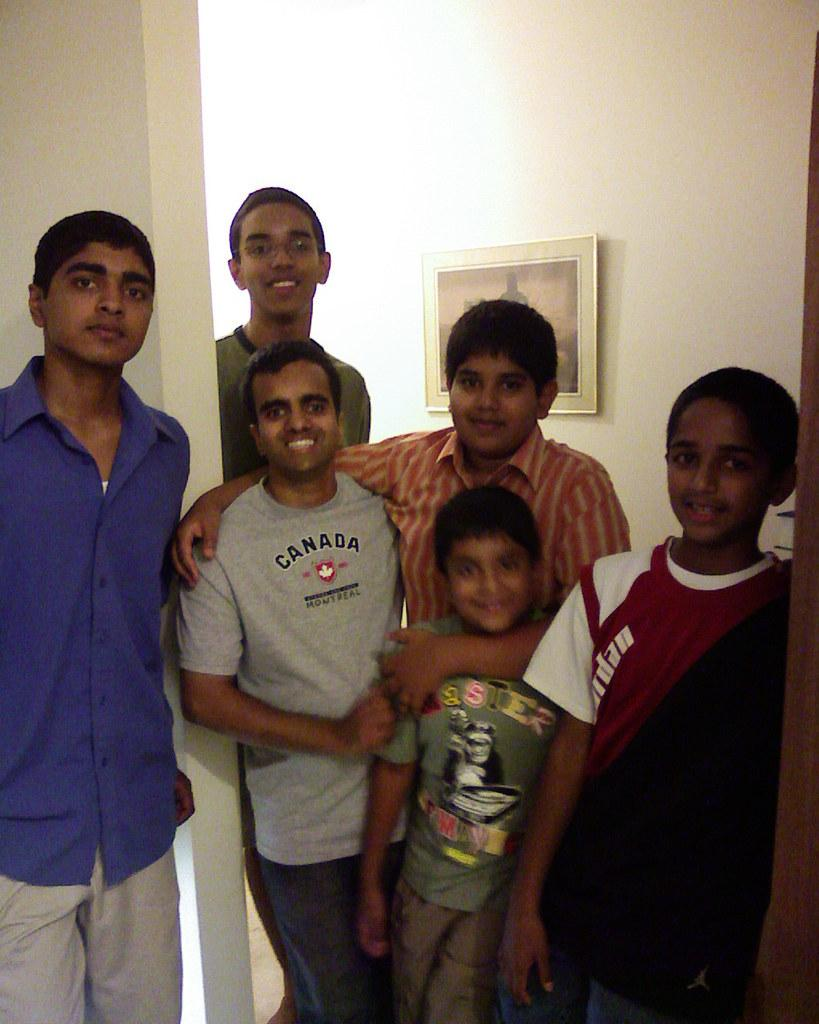What is the main subject of the image? The main subject of the image is a group of people. What are the people in the image doing? The people are standing. What can be observed about the clothing of the people in the image? The people are wearing different color dresses. What is visible in the background of the image? There is a white wall in the background of the image. How is the image framed or displayed? The frame is attached to the white wall. How many cars are parked in front of the people in the image? There are no cars visible in the image; it only features a group of people standing and wearing different color dresses. 